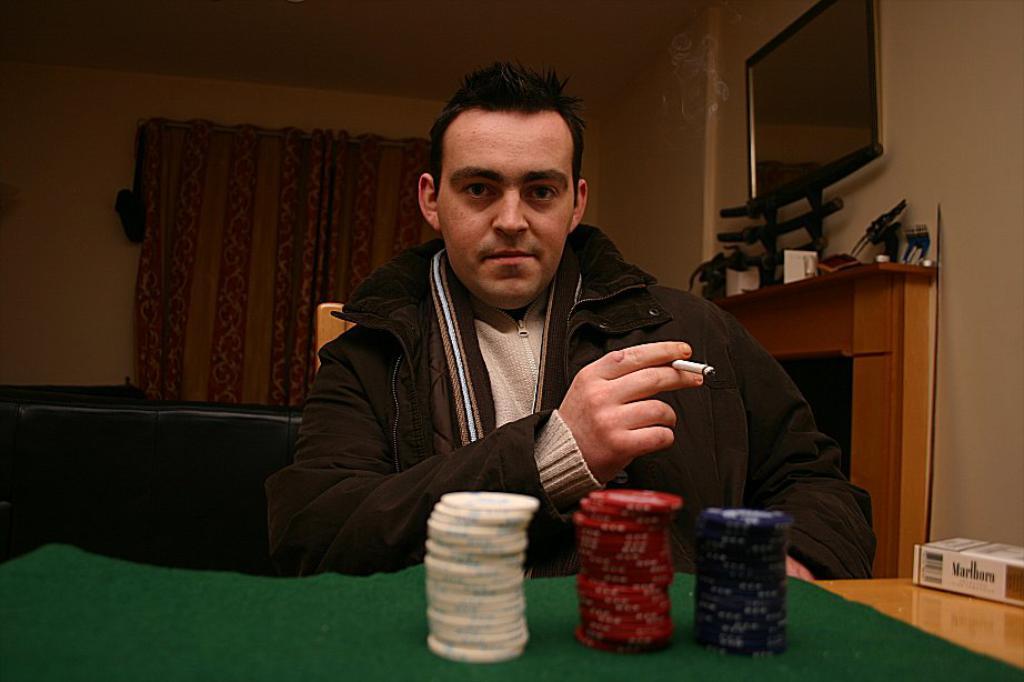Describe this image in one or two sentences. In this image there is a man sitting in a chair near the table and playing with the casino coins and there is a casino box in the table and in back ground there is television , fireplace , curtain. 